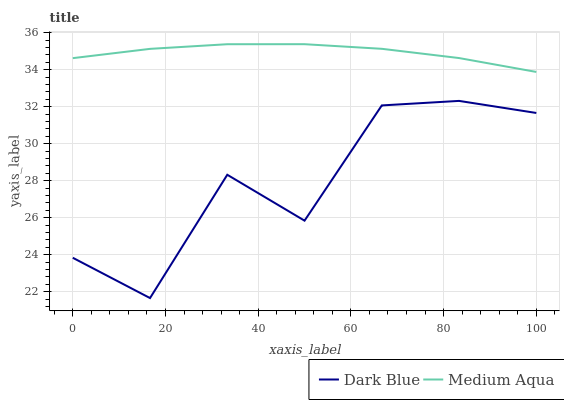Does Dark Blue have the minimum area under the curve?
Answer yes or no. Yes. Does Medium Aqua have the maximum area under the curve?
Answer yes or no. Yes. Does Medium Aqua have the minimum area under the curve?
Answer yes or no. No. Is Medium Aqua the smoothest?
Answer yes or no. Yes. Is Dark Blue the roughest?
Answer yes or no. Yes. Is Medium Aqua the roughest?
Answer yes or no. No. Does Dark Blue have the lowest value?
Answer yes or no. Yes. Does Medium Aqua have the lowest value?
Answer yes or no. No. Does Medium Aqua have the highest value?
Answer yes or no. Yes. Is Dark Blue less than Medium Aqua?
Answer yes or no. Yes. Is Medium Aqua greater than Dark Blue?
Answer yes or no. Yes. Does Dark Blue intersect Medium Aqua?
Answer yes or no. No. 